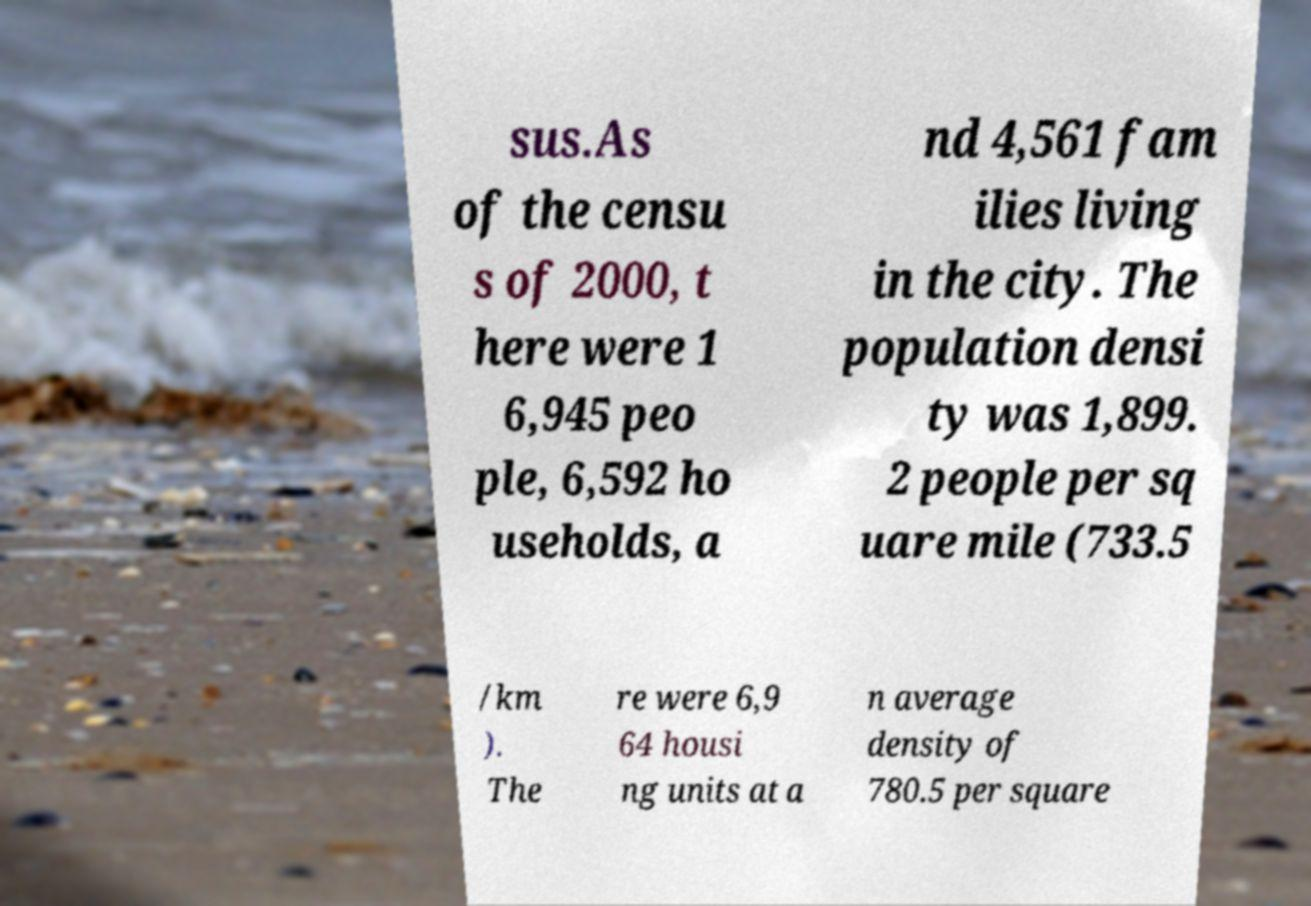Can you read and provide the text displayed in the image?This photo seems to have some interesting text. Can you extract and type it out for me? sus.As of the censu s of 2000, t here were 1 6,945 peo ple, 6,592 ho useholds, a nd 4,561 fam ilies living in the city. The population densi ty was 1,899. 2 people per sq uare mile (733.5 /km ). The re were 6,9 64 housi ng units at a n average density of 780.5 per square 